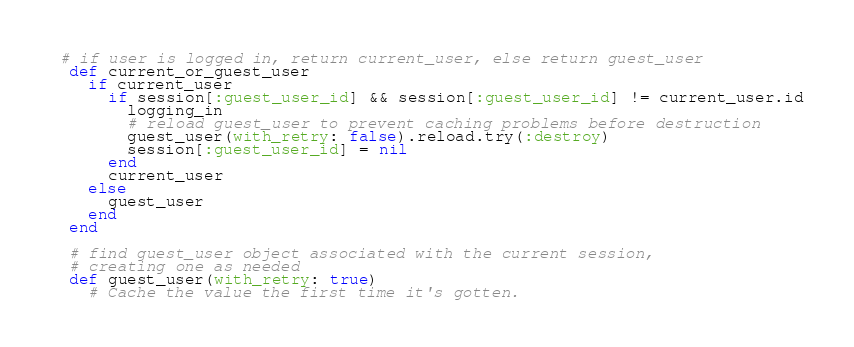<code> <loc_0><loc_0><loc_500><loc_500><_Ruby_>
 # if user is logged in, return current_user, else return guest_user
  def current_or_guest_user
    if current_user
      if session[:guest_user_id] && session[:guest_user_id] != current_user.id
        logging_in
        # reload guest_user to prevent caching problems before destruction
        guest_user(with_retry: false).reload.try(:destroy)
        session[:guest_user_id] = nil
      end
      current_user
    else
      guest_user
    end
  end

  # find guest_user object associated with the current session,
  # creating one as needed
  def guest_user(with_retry: true)
    # Cache the value the first time it's gotten.</code> 